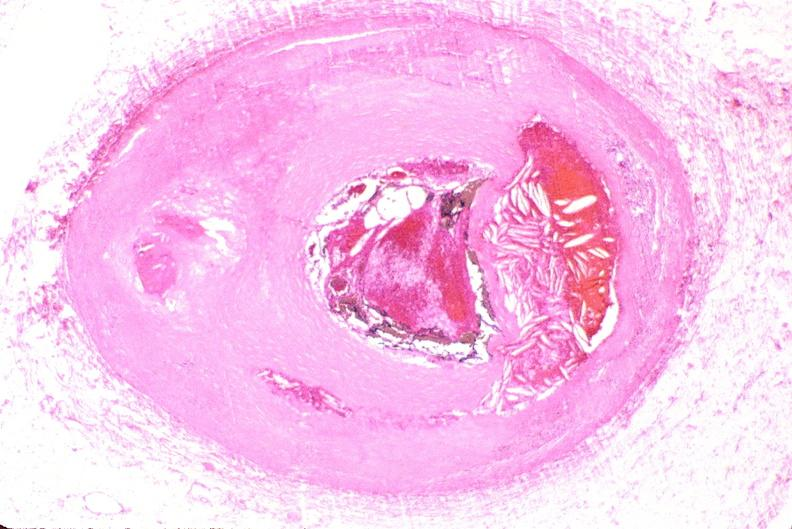s cardiovascular present?
Answer the question using a single word or phrase. Yes 